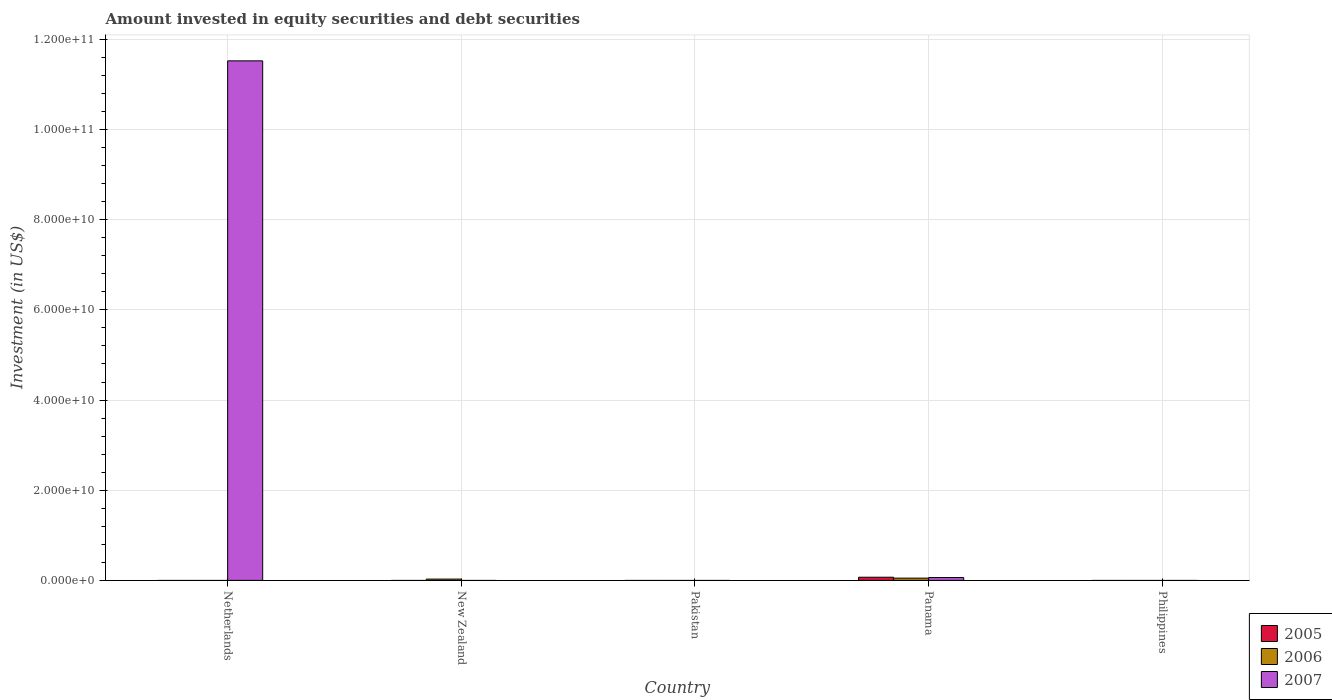How many bars are there on the 4th tick from the left?
Your answer should be very brief. 3. How many bars are there on the 5th tick from the right?
Offer a terse response. 1. What is the amount invested in equity securities and debt securities in 2007 in Netherlands?
Offer a very short reply. 1.15e+11. Across all countries, what is the maximum amount invested in equity securities and debt securities in 2005?
Offer a terse response. 7.01e+08. Across all countries, what is the minimum amount invested in equity securities and debt securities in 2007?
Provide a succinct answer. 0. In which country was the amount invested in equity securities and debt securities in 2005 maximum?
Your response must be concise. Panama. What is the total amount invested in equity securities and debt securities in 2006 in the graph?
Your response must be concise. 7.92e+08. What is the difference between the amount invested in equity securities and debt securities in 2006 in New Zealand and the amount invested in equity securities and debt securities in 2005 in Netherlands?
Your answer should be very brief. 2.91e+08. What is the average amount invested in equity securities and debt securities in 2006 per country?
Offer a terse response. 1.58e+08. What is the difference between the amount invested in equity securities and debt securities of/in 2005 and amount invested in equity securities and debt securities of/in 2006 in Panama?
Give a very brief answer. 2.00e+08. What is the ratio of the amount invested in equity securities and debt securities in 2007 in Netherlands to that in Panama?
Your answer should be very brief. 182.45. What is the difference between the highest and the lowest amount invested in equity securities and debt securities in 2007?
Your answer should be compact. 1.15e+11. Is it the case that in every country, the sum of the amount invested in equity securities and debt securities in 2005 and amount invested in equity securities and debt securities in 2007 is greater than the amount invested in equity securities and debt securities in 2006?
Your answer should be compact. No. Are all the bars in the graph horizontal?
Ensure brevity in your answer.  No. How many countries are there in the graph?
Keep it short and to the point. 5. What is the difference between two consecutive major ticks on the Y-axis?
Offer a very short reply. 2.00e+1. Does the graph contain any zero values?
Provide a short and direct response. Yes. Does the graph contain grids?
Provide a short and direct response. Yes. How many legend labels are there?
Provide a short and direct response. 3. What is the title of the graph?
Give a very brief answer. Amount invested in equity securities and debt securities. Does "2011" appear as one of the legend labels in the graph?
Your answer should be very brief. No. What is the label or title of the X-axis?
Provide a succinct answer. Country. What is the label or title of the Y-axis?
Provide a succinct answer. Investment (in US$). What is the Investment (in US$) of 2007 in Netherlands?
Your answer should be compact. 1.15e+11. What is the Investment (in US$) in 2006 in New Zealand?
Give a very brief answer. 2.91e+08. What is the Investment (in US$) in 2005 in Pakistan?
Your answer should be very brief. 0. What is the Investment (in US$) of 2006 in Pakistan?
Give a very brief answer. 0. What is the Investment (in US$) in 2005 in Panama?
Give a very brief answer. 7.01e+08. What is the Investment (in US$) of 2006 in Panama?
Your answer should be very brief. 5.01e+08. What is the Investment (in US$) in 2007 in Panama?
Keep it short and to the point. 6.32e+08. What is the Investment (in US$) in 2005 in Philippines?
Your response must be concise. 0. What is the Investment (in US$) of 2006 in Philippines?
Provide a succinct answer. 0. What is the Investment (in US$) in 2007 in Philippines?
Offer a very short reply. 0. Across all countries, what is the maximum Investment (in US$) in 2005?
Your response must be concise. 7.01e+08. Across all countries, what is the maximum Investment (in US$) of 2006?
Make the answer very short. 5.01e+08. Across all countries, what is the maximum Investment (in US$) of 2007?
Offer a terse response. 1.15e+11. Across all countries, what is the minimum Investment (in US$) in 2005?
Ensure brevity in your answer.  0. Across all countries, what is the minimum Investment (in US$) in 2006?
Provide a short and direct response. 0. What is the total Investment (in US$) of 2005 in the graph?
Your answer should be very brief. 7.01e+08. What is the total Investment (in US$) in 2006 in the graph?
Your response must be concise. 7.92e+08. What is the total Investment (in US$) in 2007 in the graph?
Offer a very short reply. 1.16e+11. What is the difference between the Investment (in US$) in 2007 in Netherlands and that in Panama?
Offer a very short reply. 1.15e+11. What is the difference between the Investment (in US$) of 2006 in New Zealand and that in Panama?
Offer a very short reply. -2.10e+08. What is the difference between the Investment (in US$) of 2006 in New Zealand and the Investment (in US$) of 2007 in Panama?
Provide a succinct answer. -3.41e+08. What is the average Investment (in US$) in 2005 per country?
Your answer should be compact. 1.40e+08. What is the average Investment (in US$) in 2006 per country?
Keep it short and to the point. 1.58e+08. What is the average Investment (in US$) in 2007 per country?
Your response must be concise. 2.32e+1. What is the difference between the Investment (in US$) of 2005 and Investment (in US$) of 2006 in Panama?
Your answer should be very brief. 2.00e+08. What is the difference between the Investment (in US$) of 2005 and Investment (in US$) of 2007 in Panama?
Keep it short and to the point. 6.92e+07. What is the difference between the Investment (in US$) in 2006 and Investment (in US$) in 2007 in Panama?
Offer a terse response. -1.31e+08. What is the ratio of the Investment (in US$) in 2007 in Netherlands to that in Panama?
Provide a succinct answer. 182.45. What is the ratio of the Investment (in US$) of 2006 in New Zealand to that in Panama?
Your answer should be very brief. 0.58. What is the difference between the highest and the lowest Investment (in US$) in 2005?
Provide a short and direct response. 7.01e+08. What is the difference between the highest and the lowest Investment (in US$) in 2006?
Provide a succinct answer. 5.01e+08. What is the difference between the highest and the lowest Investment (in US$) in 2007?
Provide a short and direct response. 1.15e+11. 